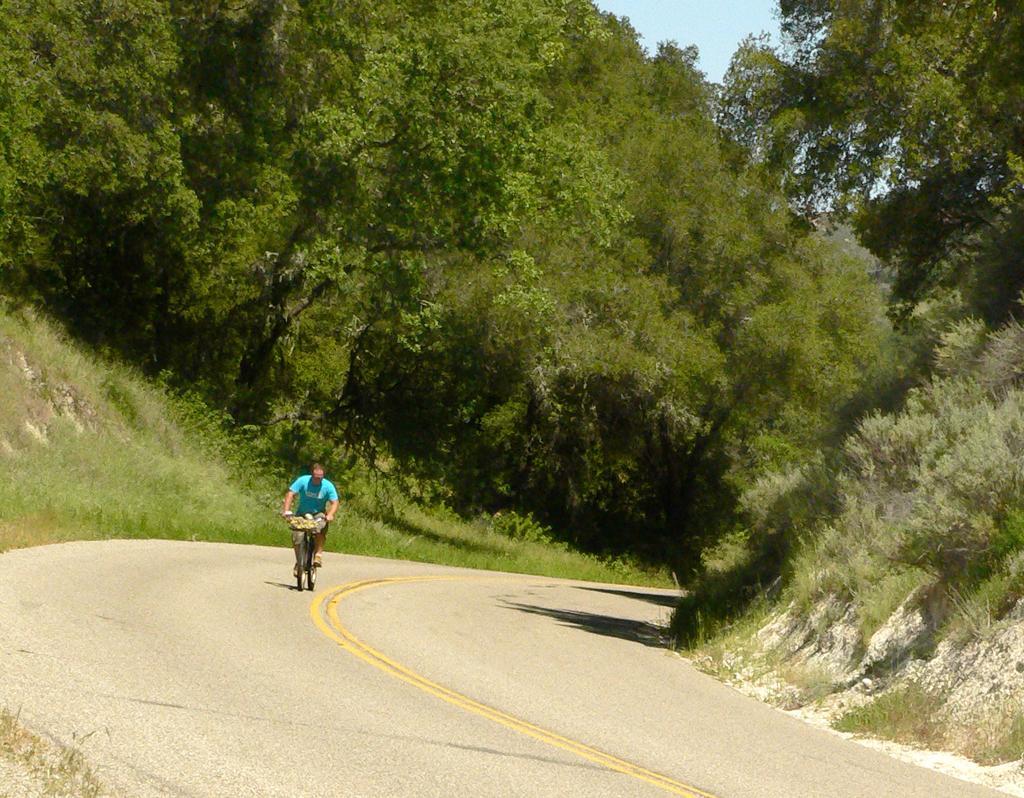How would you summarize this image in a sentence or two? In this image, we can see a person riding a bicycle on the road and in the background, there are trees. 